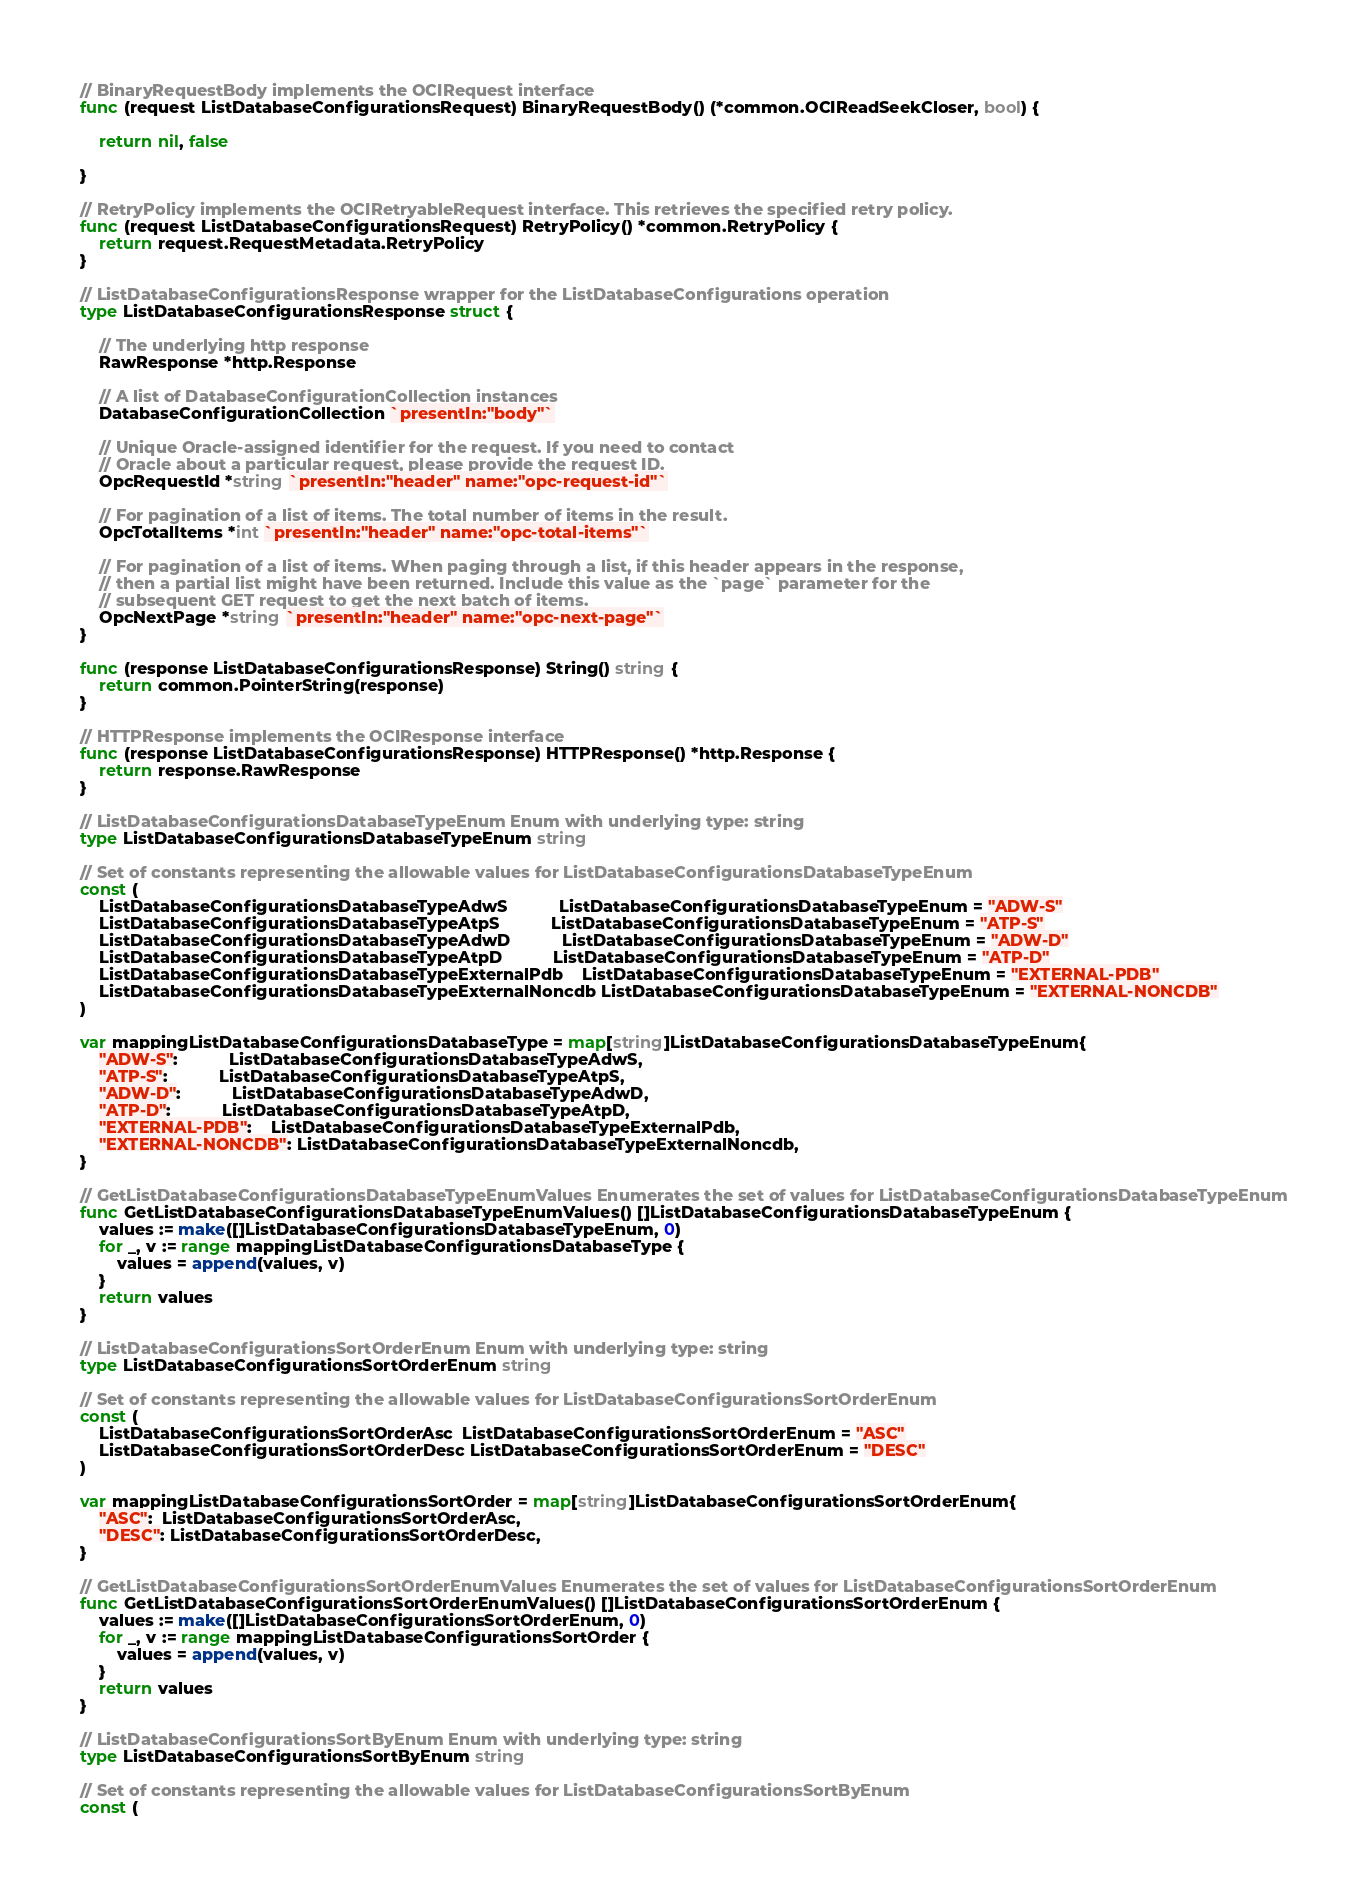<code> <loc_0><loc_0><loc_500><loc_500><_Go_>
// BinaryRequestBody implements the OCIRequest interface
func (request ListDatabaseConfigurationsRequest) BinaryRequestBody() (*common.OCIReadSeekCloser, bool) {

	return nil, false

}

// RetryPolicy implements the OCIRetryableRequest interface. This retrieves the specified retry policy.
func (request ListDatabaseConfigurationsRequest) RetryPolicy() *common.RetryPolicy {
	return request.RequestMetadata.RetryPolicy
}

// ListDatabaseConfigurationsResponse wrapper for the ListDatabaseConfigurations operation
type ListDatabaseConfigurationsResponse struct {

	// The underlying http response
	RawResponse *http.Response

	// A list of DatabaseConfigurationCollection instances
	DatabaseConfigurationCollection `presentIn:"body"`

	// Unique Oracle-assigned identifier for the request. If you need to contact
	// Oracle about a particular request, please provide the request ID.
	OpcRequestId *string `presentIn:"header" name:"opc-request-id"`

	// For pagination of a list of items. The total number of items in the result.
	OpcTotalItems *int `presentIn:"header" name:"opc-total-items"`

	// For pagination of a list of items. When paging through a list, if this header appears in the response,
	// then a partial list might have been returned. Include this value as the `page` parameter for the
	// subsequent GET request to get the next batch of items.
	OpcNextPage *string `presentIn:"header" name:"opc-next-page"`
}

func (response ListDatabaseConfigurationsResponse) String() string {
	return common.PointerString(response)
}

// HTTPResponse implements the OCIResponse interface
func (response ListDatabaseConfigurationsResponse) HTTPResponse() *http.Response {
	return response.RawResponse
}

// ListDatabaseConfigurationsDatabaseTypeEnum Enum with underlying type: string
type ListDatabaseConfigurationsDatabaseTypeEnum string

// Set of constants representing the allowable values for ListDatabaseConfigurationsDatabaseTypeEnum
const (
	ListDatabaseConfigurationsDatabaseTypeAdwS           ListDatabaseConfigurationsDatabaseTypeEnum = "ADW-S"
	ListDatabaseConfigurationsDatabaseTypeAtpS           ListDatabaseConfigurationsDatabaseTypeEnum = "ATP-S"
	ListDatabaseConfigurationsDatabaseTypeAdwD           ListDatabaseConfigurationsDatabaseTypeEnum = "ADW-D"
	ListDatabaseConfigurationsDatabaseTypeAtpD           ListDatabaseConfigurationsDatabaseTypeEnum = "ATP-D"
	ListDatabaseConfigurationsDatabaseTypeExternalPdb    ListDatabaseConfigurationsDatabaseTypeEnum = "EXTERNAL-PDB"
	ListDatabaseConfigurationsDatabaseTypeExternalNoncdb ListDatabaseConfigurationsDatabaseTypeEnum = "EXTERNAL-NONCDB"
)

var mappingListDatabaseConfigurationsDatabaseType = map[string]ListDatabaseConfigurationsDatabaseTypeEnum{
	"ADW-S":           ListDatabaseConfigurationsDatabaseTypeAdwS,
	"ATP-S":           ListDatabaseConfigurationsDatabaseTypeAtpS,
	"ADW-D":           ListDatabaseConfigurationsDatabaseTypeAdwD,
	"ATP-D":           ListDatabaseConfigurationsDatabaseTypeAtpD,
	"EXTERNAL-PDB":    ListDatabaseConfigurationsDatabaseTypeExternalPdb,
	"EXTERNAL-NONCDB": ListDatabaseConfigurationsDatabaseTypeExternalNoncdb,
}

// GetListDatabaseConfigurationsDatabaseTypeEnumValues Enumerates the set of values for ListDatabaseConfigurationsDatabaseTypeEnum
func GetListDatabaseConfigurationsDatabaseTypeEnumValues() []ListDatabaseConfigurationsDatabaseTypeEnum {
	values := make([]ListDatabaseConfigurationsDatabaseTypeEnum, 0)
	for _, v := range mappingListDatabaseConfigurationsDatabaseType {
		values = append(values, v)
	}
	return values
}

// ListDatabaseConfigurationsSortOrderEnum Enum with underlying type: string
type ListDatabaseConfigurationsSortOrderEnum string

// Set of constants representing the allowable values for ListDatabaseConfigurationsSortOrderEnum
const (
	ListDatabaseConfigurationsSortOrderAsc  ListDatabaseConfigurationsSortOrderEnum = "ASC"
	ListDatabaseConfigurationsSortOrderDesc ListDatabaseConfigurationsSortOrderEnum = "DESC"
)

var mappingListDatabaseConfigurationsSortOrder = map[string]ListDatabaseConfigurationsSortOrderEnum{
	"ASC":  ListDatabaseConfigurationsSortOrderAsc,
	"DESC": ListDatabaseConfigurationsSortOrderDesc,
}

// GetListDatabaseConfigurationsSortOrderEnumValues Enumerates the set of values for ListDatabaseConfigurationsSortOrderEnum
func GetListDatabaseConfigurationsSortOrderEnumValues() []ListDatabaseConfigurationsSortOrderEnum {
	values := make([]ListDatabaseConfigurationsSortOrderEnum, 0)
	for _, v := range mappingListDatabaseConfigurationsSortOrder {
		values = append(values, v)
	}
	return values
}

// ListDatabaseConfigurationsSortByEnum Enum with underlying type: string
type ListDatabaseConfigurationsSortByEnum string

// Set of constants representing the allowable values for ListDatabaseConfigurationsSortByEnum
const (</code> 